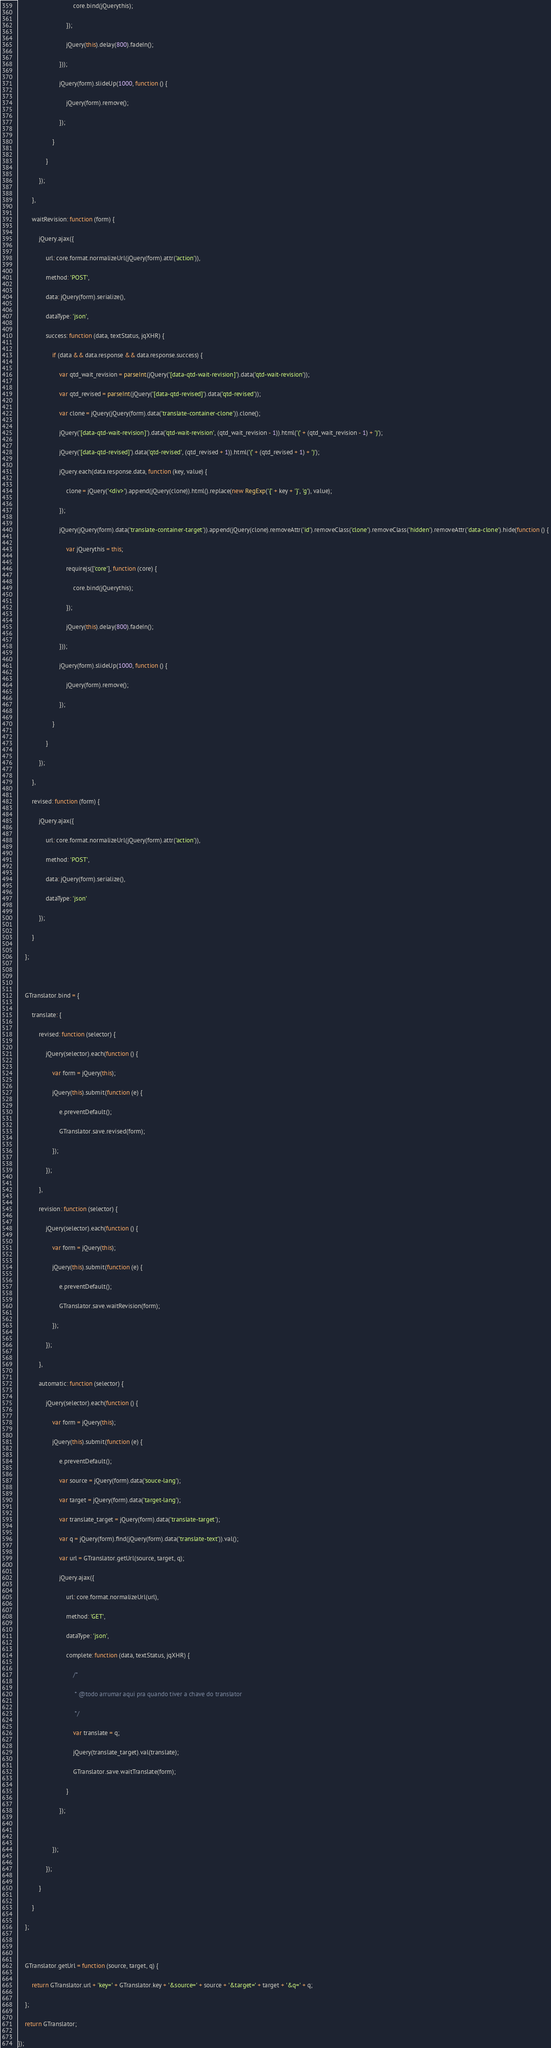Convert code to text. <code><loc_0><loc_0><loc_500><loc_500><_JavaScript_>                                core.bind(jQuerythis);
                            });
                            jQuery(this).delay(800).fadeIn();
                        }));
                        jQuery(form).slideUp(1000, function () {
                            jQuery(form).remove();
                        });
                    }
                }
            });
        },
        waitRevision: function (form) {
            jQuery.ajax({
                url: core.format.normalizeUrl(jQuery(form).attr('action')),
                method: 'POST',
                data: jQuery(form).serialize(),
                dataType: 'json',
                success: function (data, textStatus, jqXHR) {
                    if (data && data.response && data.response.success) {
                        var qtd_wait_revision = parseInt(jQuery('[data-qtd-wait-revision]').data('qtd-wait-revision'));
                        var qtd_revised = parseInt(jQuery('[data-qtd-revised]').data('qtd-revised'));
                        var clone = jQuery(jQuery(form).data('translate-container-clone')).clone();
                        jQuery('[data-qtd-wait-revision]').data('qtd-wait-revision', (qtd_wait_revision - 1)).html('(' + (qtd_wait_revision - 1) + ')');
                        jQuery('[data-qtd-revised]').data('qtd-revised', (qtd_revised + 1)).html('(' + (qtd_revised + 1) + ')');
                        jQuery.each(data.response.data, function (key, value) {
                            clone = jQuery('<div>').append(jQuery(clone)).html().replace(new RegExp('{' + key + '}', 'g'), value);
                        });
                        jQuery(jQuery(form).data('translate-container-target')).append(jQuery(clone).removeAttr('id').removeClass('clone').removeClass('hidden').removeAttr('data-clone').hide(function () {
                            var jQuerythis = this;
                            requirejs(['core'], function (core) {
                                core.bind(jQuerythis);
                            });
                            jQuery(this).delay(800).fadeIn();
                        }));
                        jQuery(form).slideUp(1000, function () {
                            jQuery(form).remove();
                        });
                    }
                }
            });
        },
        revised: function (form) {
            jQuery.ajax({
                url: core.format.normalizeUrl(jQuery(form).attr('action')),
                method: 'POST',
                data: jQuery(form).serialize(),
                dataType: 'json'
            });
        }
    };

    GTranslator.bind = {
        translate: {
            revised: function (selector) {
                jQuery(selector).each(function () {
                    var form = jQuery(this);
                    jQuery(this).submit(function (e) {
                        e.preventDefault();
                        GTranslator.save.revised(form);
                    });
                });
            },
            revision: function (selector) {
                jQuery(selector).each(function () {
                    var form = jQuery(this);
                    jQuery(this).submit(function (e) {
                        e.preventDefault();
                        GTranslator.save.waitRevision(form);
                    });
                });
            },
            automatic: function (selector) {
                jQuery(selector).each(function () {
                    var form = jQuery(this);
                    jQuery(this).submit(function (e) {
                        e.preventDefault();
                        var source = jQuery(form).data('souce-lang');
                        var target = jQuery(form).data('target-lang');
                        var translate_target = jQuery(form).data('translate-target');
                        var q = jQuery(form).find(jQuery(form).data('translate-text')).val();
                        var url = GTranslator.getUrl(source, target, q);
                        jQuery.ajax({
                            url: core.format.normalizeUrl(url),
                            method: 'GET',
                            dataType: 'json',
                            complete: function (data, textStatus, jqXHR) {
                                /*
                                 * @todo arrumar aqui pra quando tiver a chave do translator
                                 */
                                var translate = q;
                                jQuery(translate_target).val(translate);
                                GTranslator.save.waitTranslate(form);
                            }
                        });

                    });
                });
            }
        }
    };

    GTranslator.getUrl = function (source, target, q) {
        return GTranslator.url + 'key=' + GTranslator.key + '&source=' + source + '&target=' + target + '&q=' + q;
    };
    return GTranslator;
});</code> 